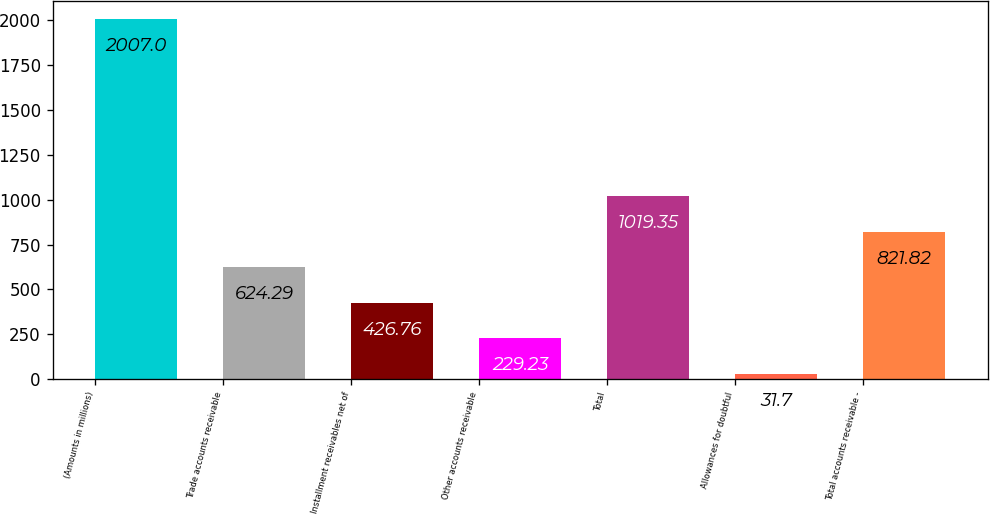<chart> <loc_0><loc_0><loc_500><loc_500><bar_chart><fcel>(Amounts in millions)<fcel>Trade accounts receivable<fcel>Installment receivables net of<fcel>Other accounts receivable<fcel>Total<fcel>Allowances for doubtful<fcel>Total accounts receivable -<nl><fcel>2007<fcel>624.29<fcel>426.76<fcel>229.23<fcel>1019.35<fcel>31.7<fcel>821.82<nl></chart> 